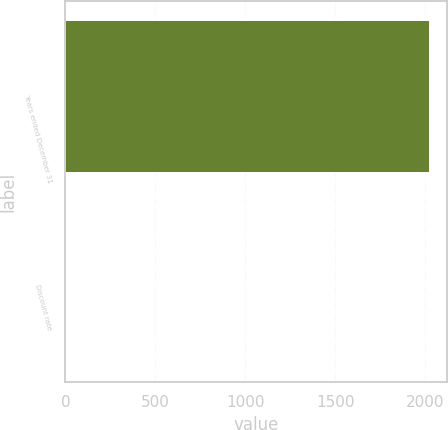Convert chart. <chart><loc_0><loc_0><loc_500><loc_500><bar_chart><fcel>Years ended December 31<fcel>Discount rate<nl><fcel>2017<fcel>4.2<nl></chart> 